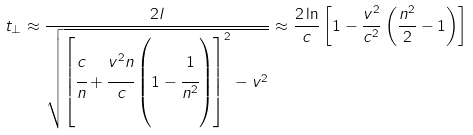Convert formula to latex. <formula><loc_0><loc_0><loc_500><loc_500>t _ { \perp } \approx \frac { 2 l } { \sqrt { \left [ \cfrac { c } { n } + \cfrac { v ^ { 2 } n } { c } \left ( 1 - \cfrac { 1 } { n ^ { 2 } } \right ) \right ] ^ { 2 } - v ^ { 2 } } } \approx \frac { 2 \ln } { c } \left [ 1 - \frac { v ^ { 2 } } { c ^ { 2 } } \left ( \frac { n ^ { 2 } } { 2 } - 1 \right ) \right ]</formula> 